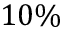<formula> <loc_0><loc_0><loc_500><loc_500>1 0 \%</formula> 